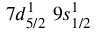Convert formula to latex. <formula><loc_0><loc_0><loc_500><loc_500>7 d _ { 5 / 2 } ^ { 1 } \, 9 s _ { 1 / 2 } ^ { 1 }</formula> 